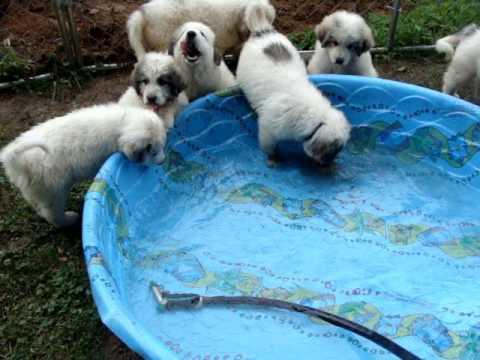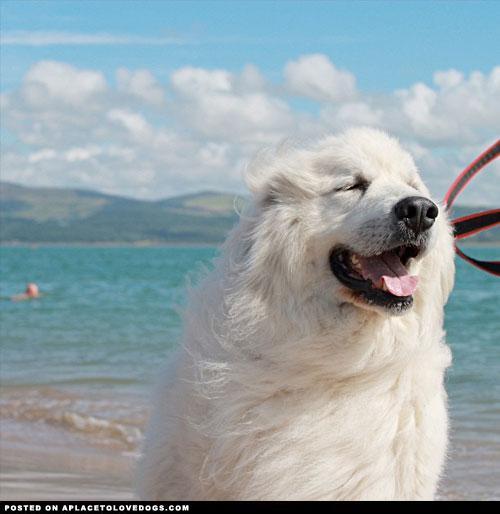The first image is the image on the left, the second image is the image on the right. Given the left and right images, does the statement "At least one image shows a dog actually swimming in a pool." hold true? Answer yes or no. No. 